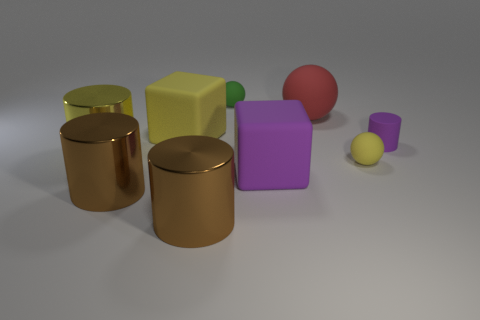Are there more big matte spheres in front of the yellow block than metal cylinders?
Your response must be concise. No. Are there any large shiny cylinders of the same color as the big ball?
Give a very brief answer. No. The matte sphere that is the same size as the yellow block is what color?
Your answer should be very brief. Red. There is a purple rubber object that is on the left side of the small purple rubber thing; is there a big rubber thing on the right side of it?
Provide a succinct answer. Yes. There is a tiny object behind the red thing; what material is it?
Offer a terse response. Rubber. Are the large yellow thing that is on the right side of the yellow cylinder and the small thing that is in front of the small purple cylinder made of the same material?
Give a very brief answer. Yes. Is the number of cylinders behind the large yellow matte thing the same as the number of big yellow matte things that are on the right side of the large purple matte object?
Your answer should be very brief. Yes. How many purple cylinders have the same material as the big red ball?
Provide a succinct answer. 1. There is a large thing that is the same color as the matte cylinder; what shape is it?
Your answer should be very brief. Cube. There is a purple object in front of the small sphere to the right of the green sphere; what is its size?
Ensure brevity in your answer.  Large. 